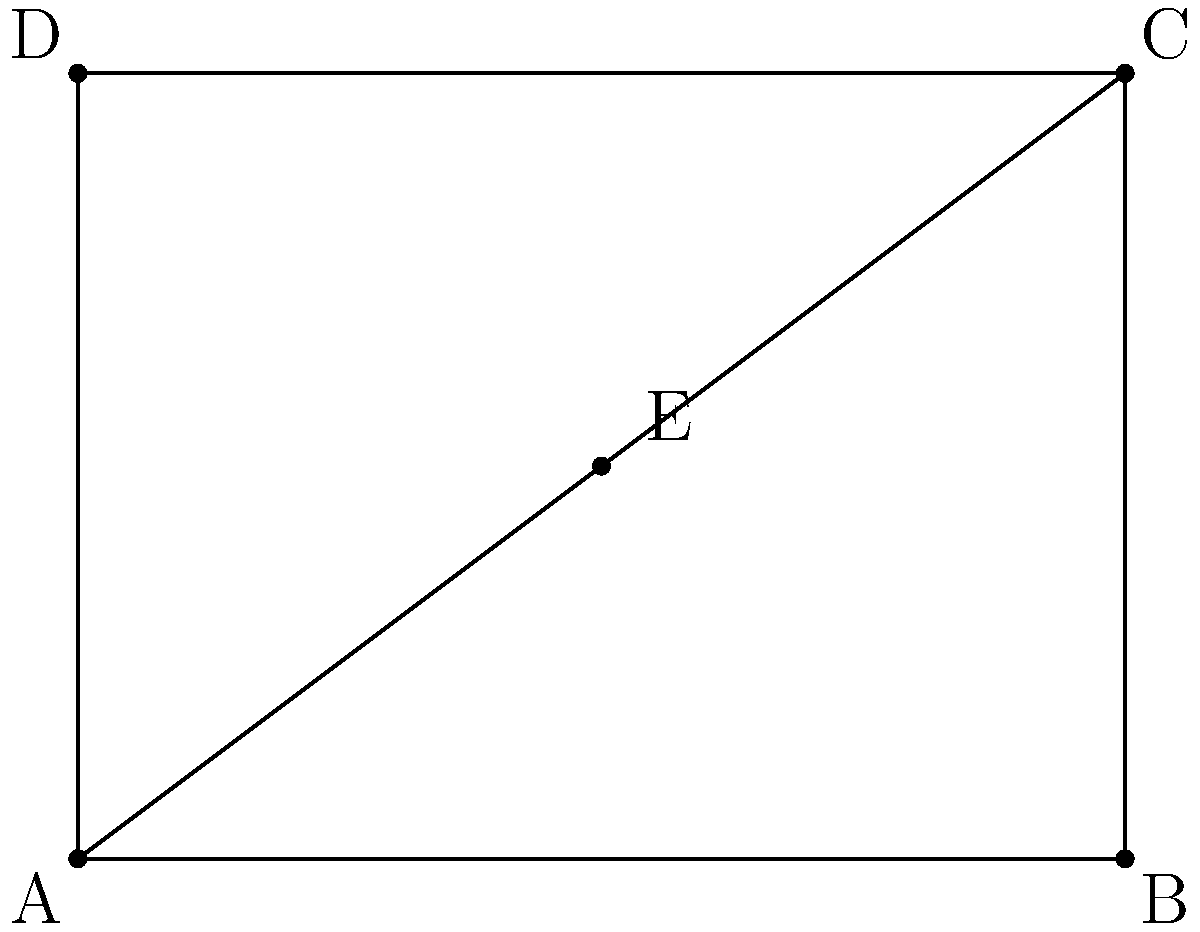In figure drawing, understanding proportions is crucial. Given the rectangle ABCD representing a canvas, point E divides both AC and BD in a specific ratio. If the area of triangle AEC is 6 square units, what is the total area of the canvas? How does this relate to the concept of scaling in figure drawing? Let's approach this step-by-step:

1) First, we need to determine the ratio in which E divides AC and BD. From the diagram, we can see that E is at the center of the rectangle.

2) This means E divides both AC and BD in a 1:1 ratio, or in other words, it's exactly halfway.

3) Given that the area of triangle AEC is 6 square units, we can use this to find the dimensions of the rectangle.

4) The area of a triangle is given by the formula: $A = \frac{1}{2} \times base \times height$

5) In this case, AB is the base and DE is the height of triangle AEC. Let's say AB = x and DE = y.

6) So, $6 = \frac{1}{2} \times x \times y$

7) We also know that triangle AEC is half of the rectangle ABCD. Therefore, the area of ABCD is 12 square units.

8) The area of a rectangle is given by length × width. So, $xy = 12$

9) From steps 6 and 8, we can conclude that $x = 4$ and $y = 3$.

10) Therefore, the total area of the canvas (rectangle ABCD) is $4 \times 3 = 12$ square units.

This relates to scaling in figure drawing because artists often use grids or proportional divisions to accurately transfer or scale their drawings. By understanding that the central point E creates equal divisions, an artist can easily scale their drawing up or down while maintaining proper proportions.
Answer: 12 square units 